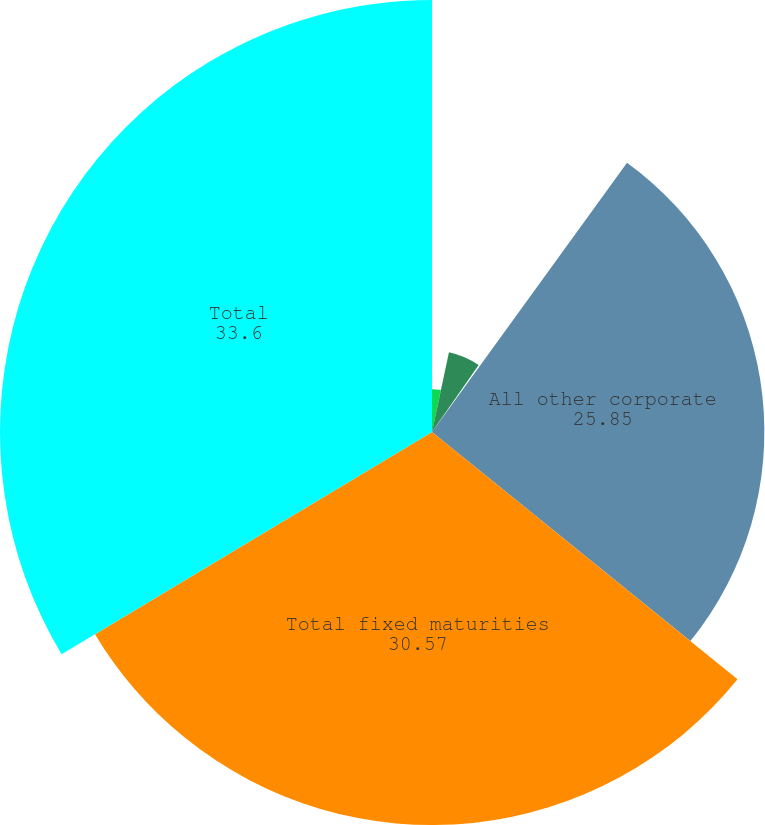Convert chart. <chart><loc_0><loc_0><loc_500><loc_500><pie_chart><fcel>US government agencies and<fcel>States municipalities and<fcel>Foreign governments<fcel>All other corporate<fcel>Total fixed maturities<fcel>Total<nl><fcel>3.33%<fcel>6.35%<fcel>0.3%<fcel>25.85%<fcel>30.57%<fcel>33.6%<nl></chart> 